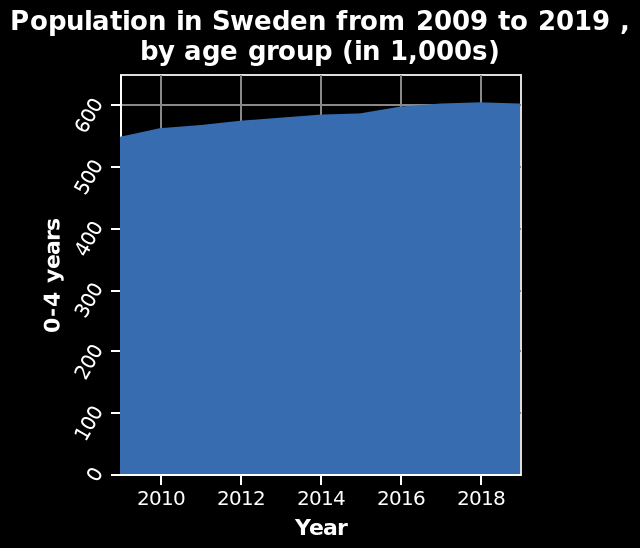<image>
please describe the details of the chart Population in Sweden from 2009 to 2019 , by age group (in 1,000s) is a area plot. On the x-axis, Year is defined with a linear scale from 2010 to 2018. There is a linear scale of range 0 to 600 on the y-axis, marked 0-4 years. Is the population in Sweden from 2009 to 2019, by age group (in 1,000s), represented as a line graph? No.Population in Sweden from 2009 to 2019 , by age group (in 1,000s) is a area plot. On the x-axis, Year is defined with a linear scale from 2010 to 2018. There is a linear scale of range 0 to 600 on the y-axis, marked 0-4 years. 